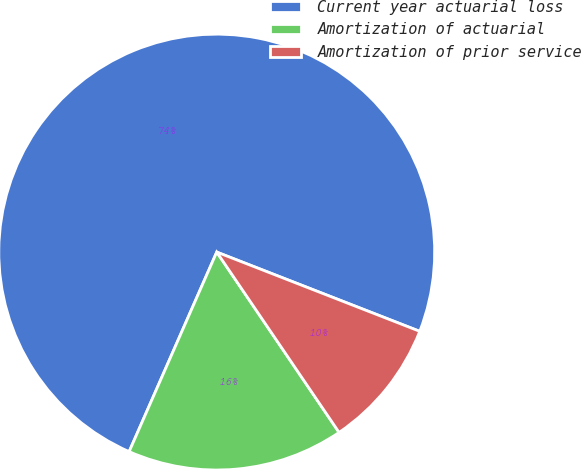Convert chart. <chart><loc_0><loc_0><loc_500><loc_500><pie_chart><fcel>Current year actuarial loss<fcel>Amortization of actuarial<fcel>Amortization of prior service<nl><fcel>74.34%<fcel>16.07%<fcel>9.59%<nl></chart> 